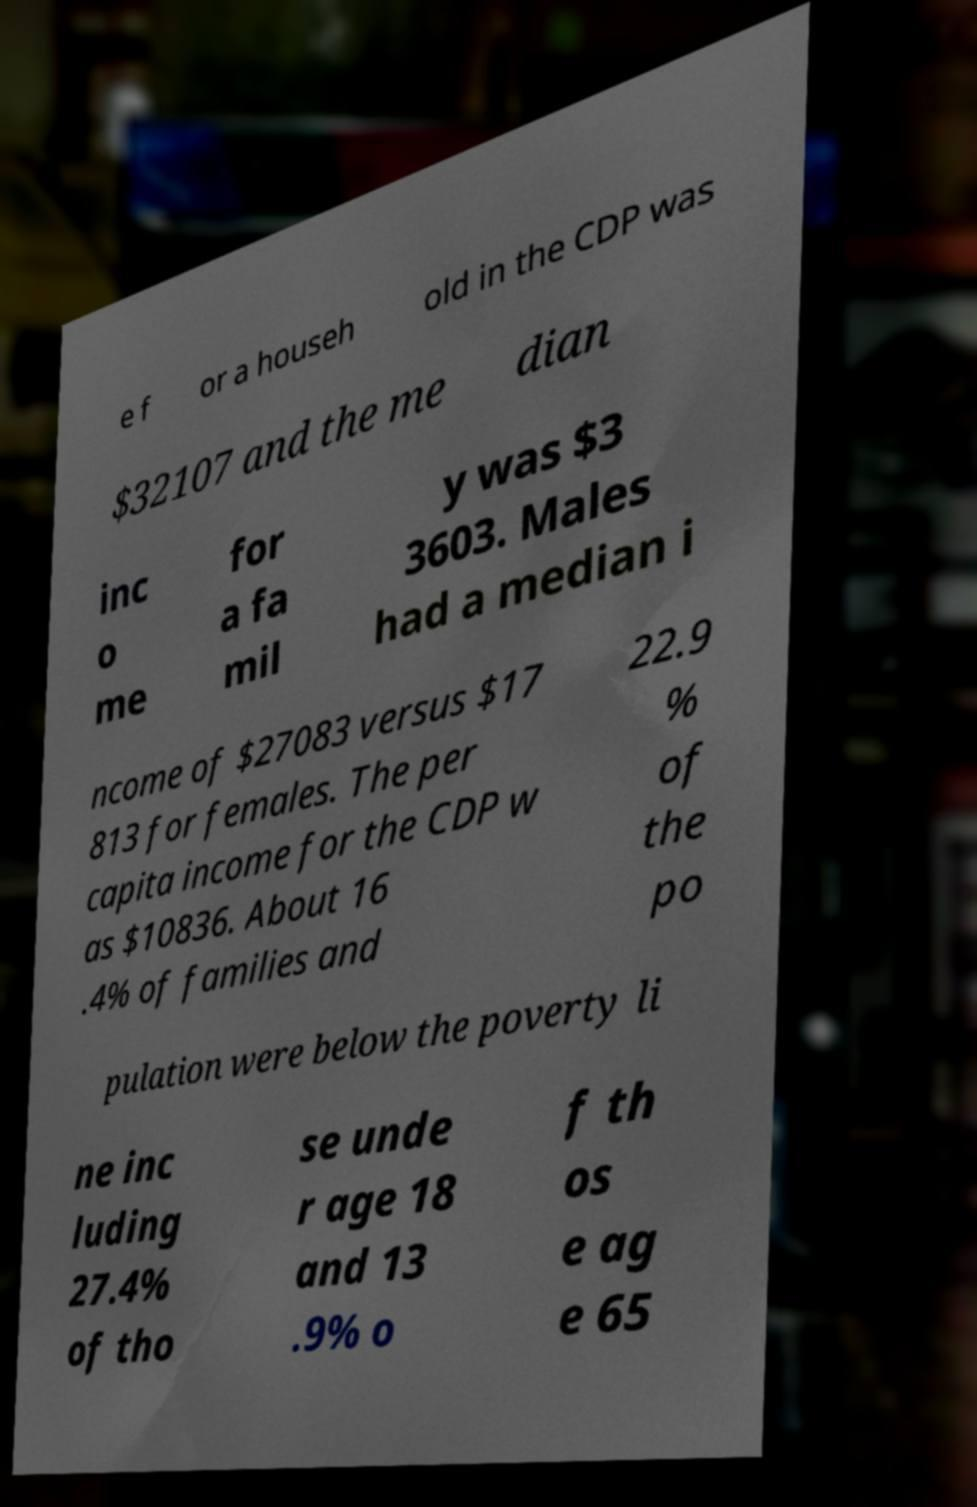Please read and relay the text visible in this image. What does it say? e f or a househ old in the CDP was $32107 and the me dian inc o me for a fa mil y was $3 3603. Males had a median i ncome of $27083 versus $17 813 for females. The per capita income for the CDP w as $10836. About 16 .4% of families and 22.9 % of the po pulation were below the poverty li ne inc luding 27.4% of tho se unde r age 18 and 13 .9% o f th os e ag e 65 